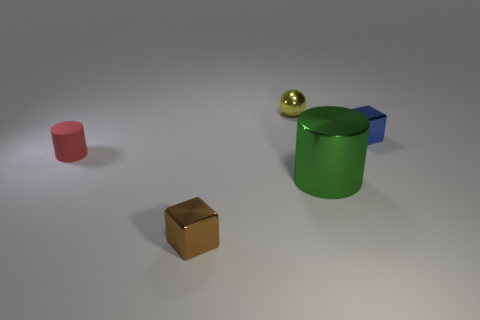Add 2 tiny things. How many objects exist? 7 Subtract all blocks. How many objects are left? 3 Add 1 small yellow balls. How many small yellow balls exist? 2 Subtract 0 green balls. How many objects are left? 5 Subtract all brown blocks. Subtract all small cylinders. How many objects are left? 3 Add 1 red things. How many red things are left? 2 